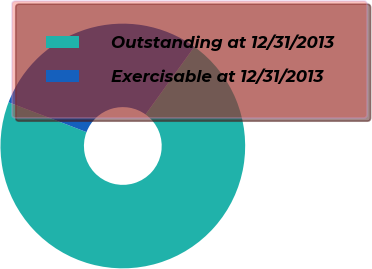<chart> <loc_0><loc_0><loc_500><loc_500><pie_chart><fcel>Outstanding at 12/31/2013<fcel>Exercisable at 12/31/2013<nl><fcel>70.88%<fcel>29.12%<nl></chart> 